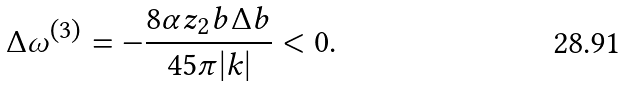Convert formula to latex. <formula><loc_0><loc_0><loc_500><loc_500>\Delta \omega ^ { ( 3 ) } = - \frac { 8 \alpha z _ { 2 } b \Delta b } { 4 5 \pi | k | } < 0 .</formula> 